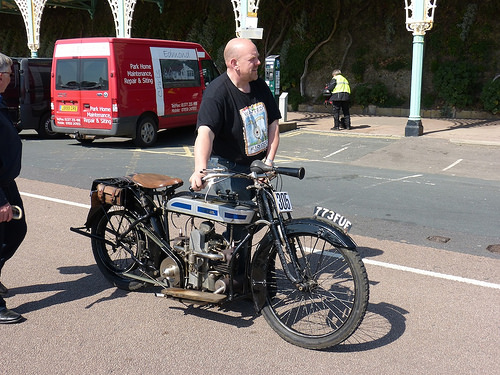<image>
Is there a man in the van? No. The man is not contained within the van. These objects have a different spatial relationship. 